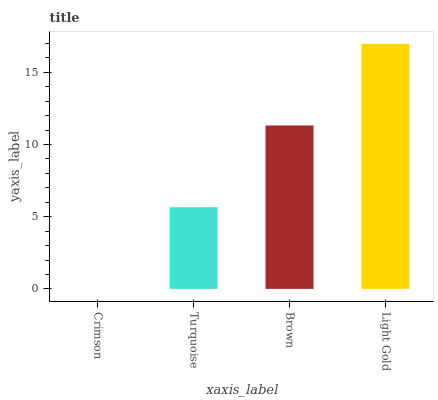Is Crimson the minimum?
Answer yes or no. Yes. Is Light Gold the maximum?
Answer yes or no. Yes. Is Turquoise the minimum?
Answer yes or no. No. Is Turquoise the maximum?
Answer yes or no. No. Is Turquoise greater than Crimson?
Answer yes or no. Yes. Is Crimson less than Turquoise?
Answer yes or no. Yes. Is Crimson greater than Turquoise?
Answer yes or no. No. Is Turquoise less than Crimson?
Answer yes or no. No. Is Brown the high median?
Answer yes or no. Yes. Is Turquoise the low median?
Answer yes or no. Yes. Is Crimson the high median?
Answer yes or no. No. Is Brown the low median?
Answer yes or no. No. 